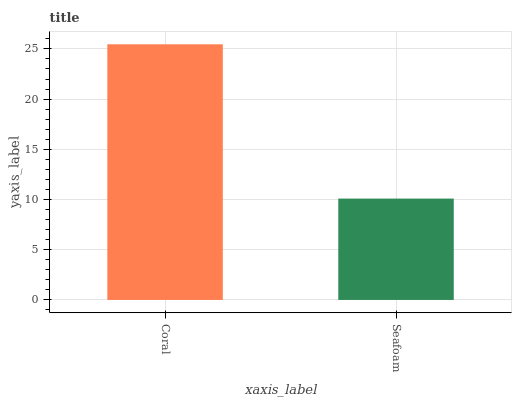Is Seafoam the minimum?
Answer yes or no. Yes. Is Coral the maximum?
Answer yes or no. Yes. Is Seafoam the maximum?
Answer yes or no. No. Is Coral greater than Seafoam?
Answer yes or no. Yes. Is Seafoam less than Coral?
Answer yes or no. Yes. Is Seafoam greater than Coral?
Answer yes or no. No. Is Coral less than Seafoam?
Answer yes or no. No. Is Coral the high median?
Answer yes or no. Yes. Is Seafoam the low median?
Answer yes or no. Yes. Is Seafoam the high median?
Answer yes or no. No. Is Coral the low median?
Answer yes or no. No. 